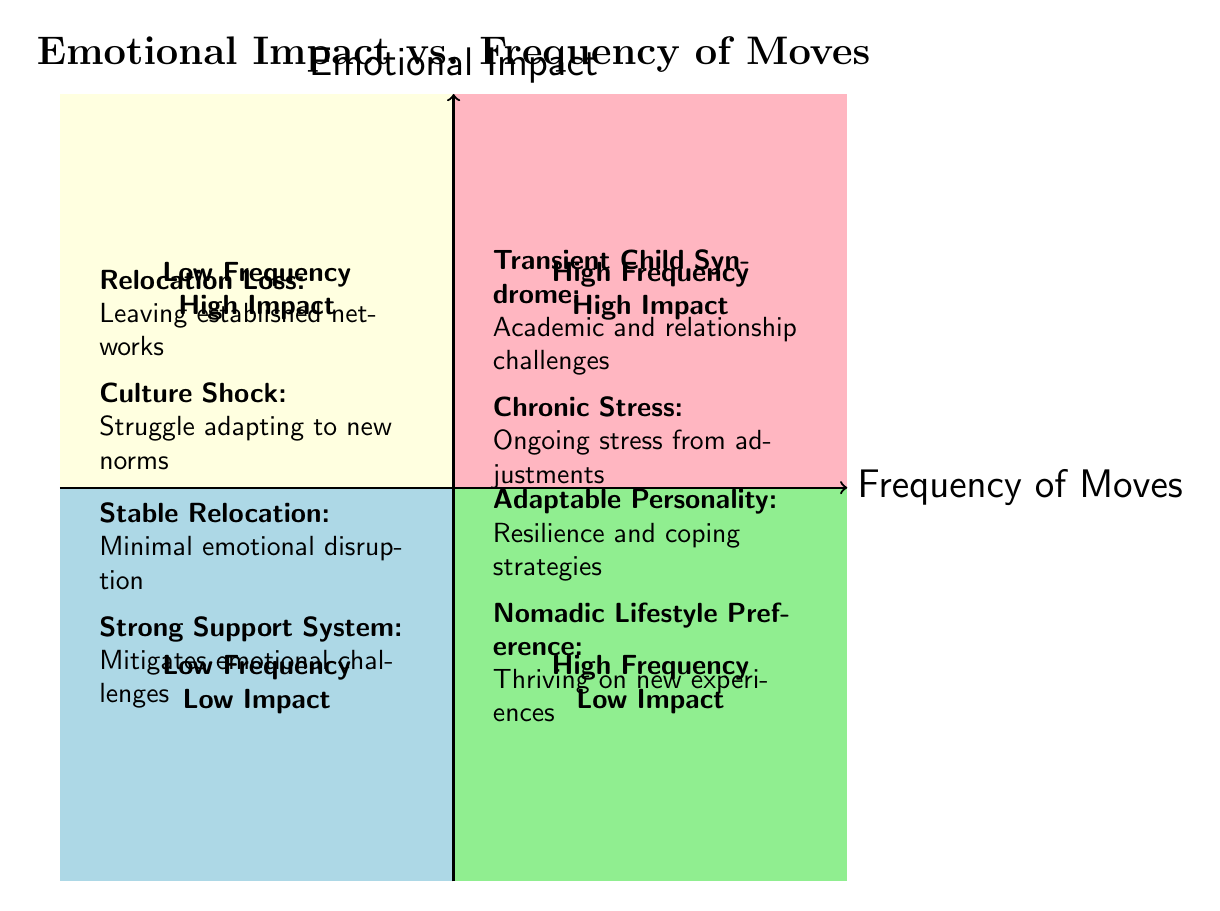What types are found in the High Frequency High Emotional Impact quadrant? The High Frequency High Emotional Impact quadrant contains two types: "Transient Child Syndrome" and "Chronic Stress." Both types are labeled in that quadrant in the diagram.
Answer: Transient Child Syndrome, Chronic Stress How many types are categorized under Low Frequency Low Emotional Impact? The Low Frequency Low Emotional Impact quadrant includes two types: "Stable Relocation" and "Strong Support System." The diagram visually shows two entries in that quadrant.
Answer: 2 Which quadrant describes individuals who thrive on new experiences? The quadrant which describes individuals who thrive on new experiences is the High Frequency Low Emotional Impact quadrant, which includes "Nomadic Lifestyle Preference." This type is explicitly cited in that segment of the diagram.
Answer: High Frequency Low Emotional Impact What emotional impact is associated with infrequent relocations? The Low Frequency High Emotional Impact quadrant indicates emotional impacts associated with infrequent relocations, specifically "Relocation Loss" and "Culture Shock," both indicated as high-impact scenarios for individuals relocating less frequently.
Answer: Relocation Loss, Culture Shock How do individuals in the High Frequency Low Emotional Impact quadrant cope with their situation? Individuals in the High Frequency Low Emotional Impact quadrant typically have some level of adaptability, reflected in types like "Adaptable Personality" and "Nomadic Lifestyle Preference." They develop coping strategies that make frequent moves less challenging. Therefore, their resilience is significant.
Answer: Resilience and coping strategies What is the main challenge faced by individuals in the Low Frequency High Emotional Impact quadrant? The main challenge faced by individuals in the Low Frequency High Emotional Impact quadrant revolves around emotional loss and cultural adaptation, specifically indicated by "Relocation Loss" and "Culture Shock." Both types highlight the emotional struggles during infrequent relocations.
Answer: Emotional loss and cultural adaptation Which quadrant has situations characterized by minimal emotional disruption? The quadrant characterized by minimal emotional disruption is the Low Frequency Low Emotional Impact quadrant, which designates "Stable Relocation" and "Strong Support System" as conditions that lead to this experience of stability.
Answer: Low Frequency Low Emotional Impact What is a common reason for chronic stress in highly mobile individuals? "Chronic Stress" is a common reason highlighted in the High Frequency High Emotional Impact quadrant, indicating ongoing stress from frequent adjustments that individuals face in their environments.
Answer: Chronic Stress Which type reflects academic challenges due to frequent relocations? "Transient Child Syndrome," located in the High Frequency High Emotional Impact quadrant, reflects academic challenges faced by children and adolescents when frequently relocating, according to the diagram's specified types.
Answer: Transient Child Syndrome 